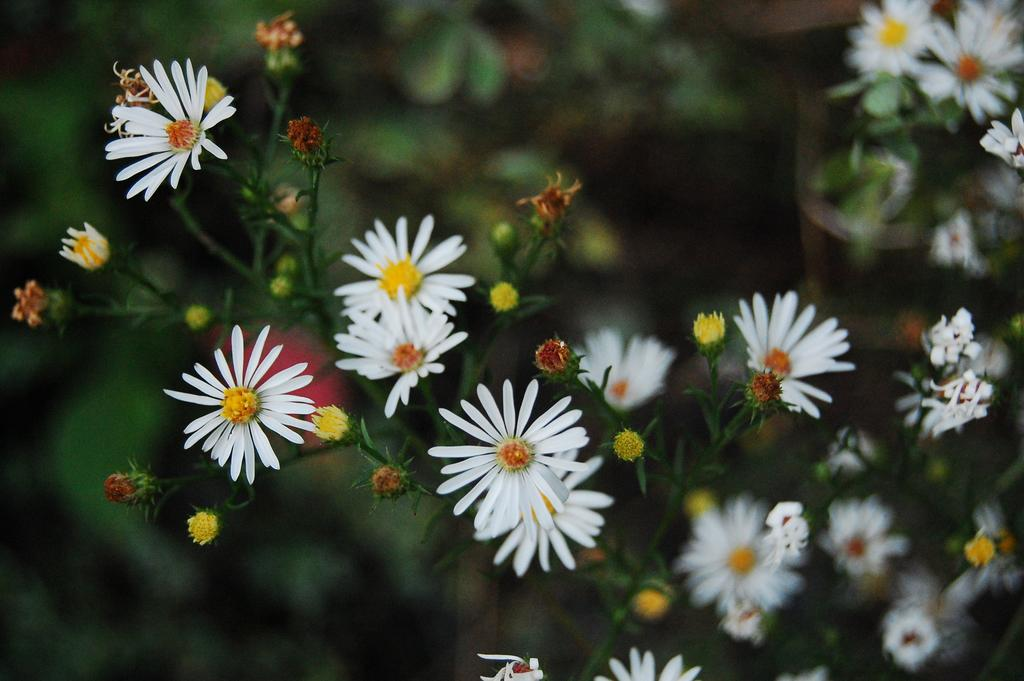What is located in the foreground of the image? There are flowers in the foreground of the image. What can be seen in the background of the image? There are plants in the background of the image. What type of metal can be seen at the bottom of the lake in the image? There is no lake or metal present in the image; it features flowers in the foreground and plants in the background. 